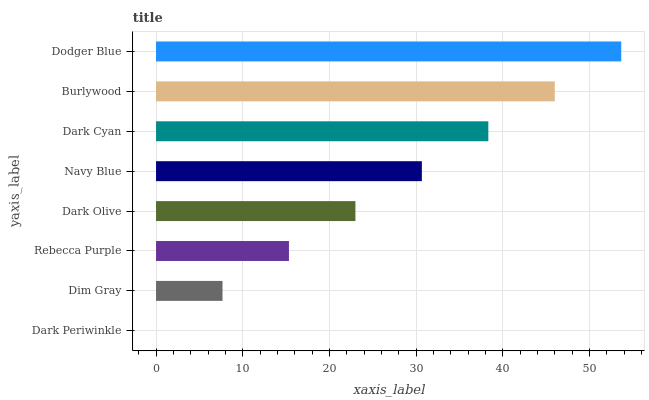Is Dark Periwinkle the minimum?
Answer yes or no. Yes. Is Dodger Blue the maximum?
Answer yes or no. Yes. Is Dim Gray the minimum?
Answer yes or no. No. Is Dim Gray the maximum?
Answer yes or no. No. Is Dim Gray greater than Dark Periwinkle?
Answer yes or no. Yes. Is Dark Periwinkle less than Dim Gray?
Answer yes or no. Yes. Is Dark Periwinkle greater than Dim Gray?
Answer yes or no. No. Is Dim Gray less than Dark Periwinkle?
Answer yes or no. No. Is Navy Blue the high median?
Answer yes or no. Yes. Is Dark Olive the low median?
Answer yes or no. Yes. Is Dark Periwinkle the high median?
Answer yes or no. No. Is Navy Blue the low median?
Answer yes or no. No. 